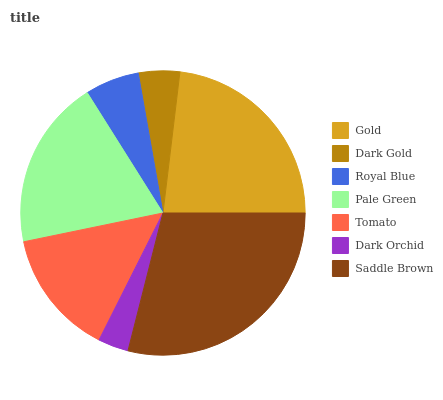Is Dark Orchid the minimum?
Answer yes or no. Yes. Is Saddle Brown the maximum?
Answer yes or no. Yes. Is Dark Gold the minimum?
Answer yes or no. No. Is Dark Gold the maximum?
Answer yes or no. No. Is Gold greater than Dark Gold?
Answer yes or no. Yes. Is Dark Gold less than Gold?
Answer yes or no. Yes. Is Dark Gold greater than Gold?
Answer yes or no. No. Is Gold less than Dark Gold?
Answer yes or no. No. Is Tomato the high median?
Answer yes or no. Yes. Is Tomato the low median?
Answer yes or no. Yes. Is Royal Blue the high median?
Answer yes or no. No. Is Royal Blue the low median?
Answer yes or no. No. 